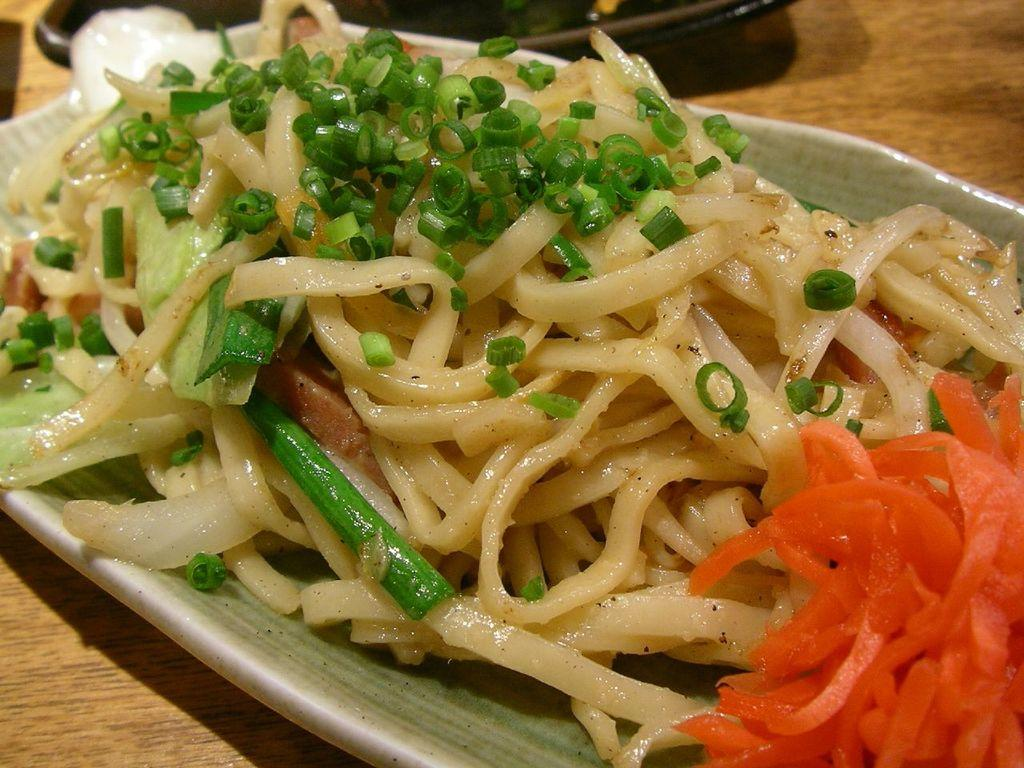What is on the plate that is visible in the image? The plate contains spaghetti, spring onions, pieces of cabbage, and carrot pieces. Where is the plate placed in the image? The plate is placed on a wooden table. What news is being discussed at the meeting in the image? There is no meeting or news present in the image; it features a plate of food on a wooden table. 